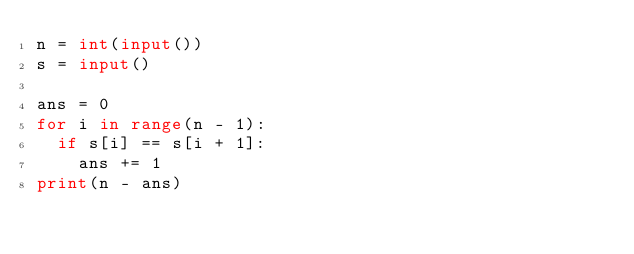Convert code to text. <code><loc_0><loc_0><loc_500><loc_500><_Python_>n = int(input())
s = input()

ans = 0
for i in range(n - 1):
  if s[i] == s[i + 1]:
    ans += 1
print(n - ans)
</code> 